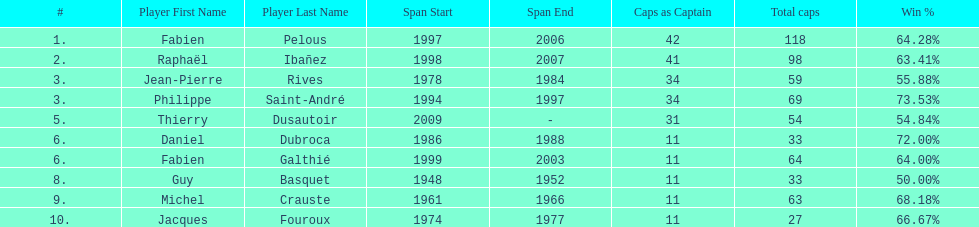Which player has the highest win percentage? Philippe Saint-André. 